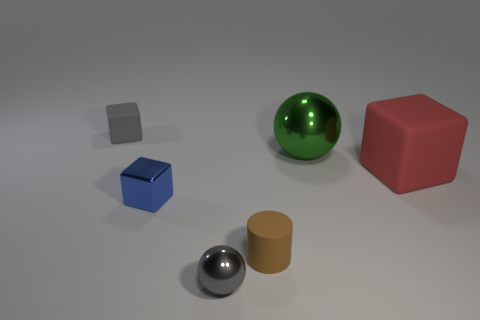Are there fewer rubber cylinders right of the small matte cylinder than small gray shiny spheres that are on the right side of the large cube?
Make the answer very short. No. What is the shape of the tiny metallic object that is the same color as the small rubber block?
Keep it short and to the point. Sphere. What number of cylinders are the same size as the green sphere?
Your answer should be very brief. 0. Is the material of the tiny object in front of the small brown cylinder the same as the gray block?
Offer a very short reply. No. Are any tiny red rubber cylinders visible?
Ensure brevity in your answer.  No. What size is the red cube that is made of the same material as the small cylinder?
Offer a very short reply. Large. Are there any small metallic spheres of the same color as the tiny rubber block?
Offer a terse response. Yes. There is a matte cube in front of the large metallic sphere; is its color the same as the thing that is behind the green metal sphere?
Make the answer very short. No. What size is the rubber thing that is the same color as the small metallic sphere?
Make the answer very short. Small. Are there any large cyan balls made of the same material as the tiny cylinder?
Your answer should be very brief. No. 